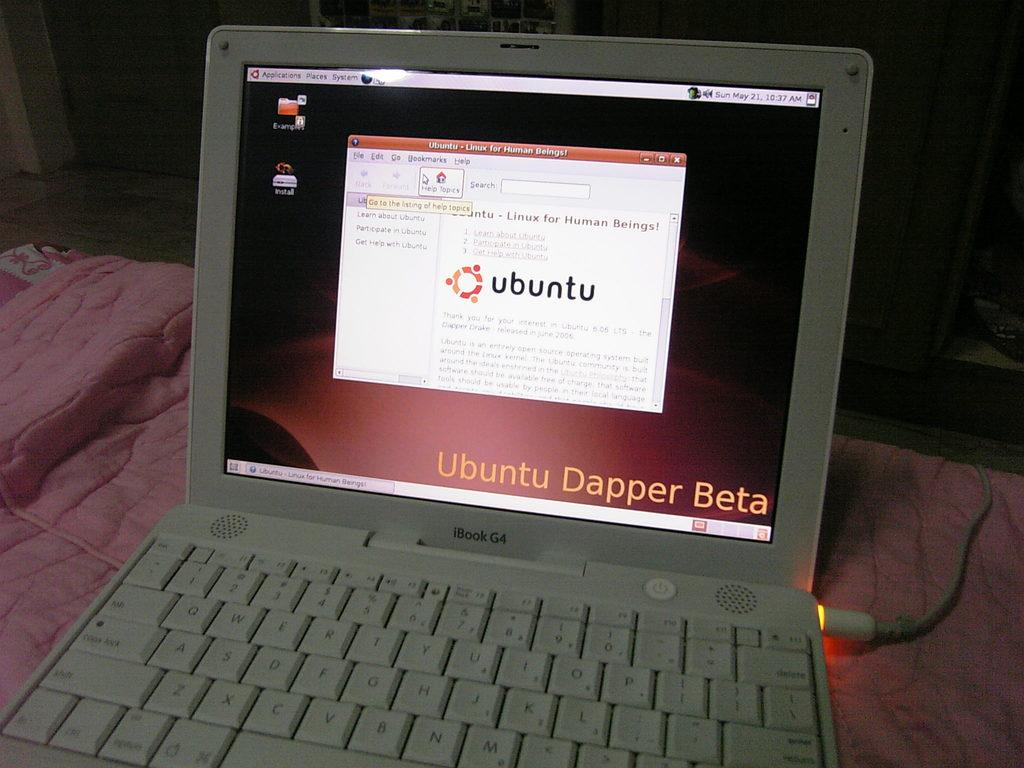<image>
Relay a brief, clear account of the picture shown. A Mac iBook computer is running an installation of Ubuntu. 